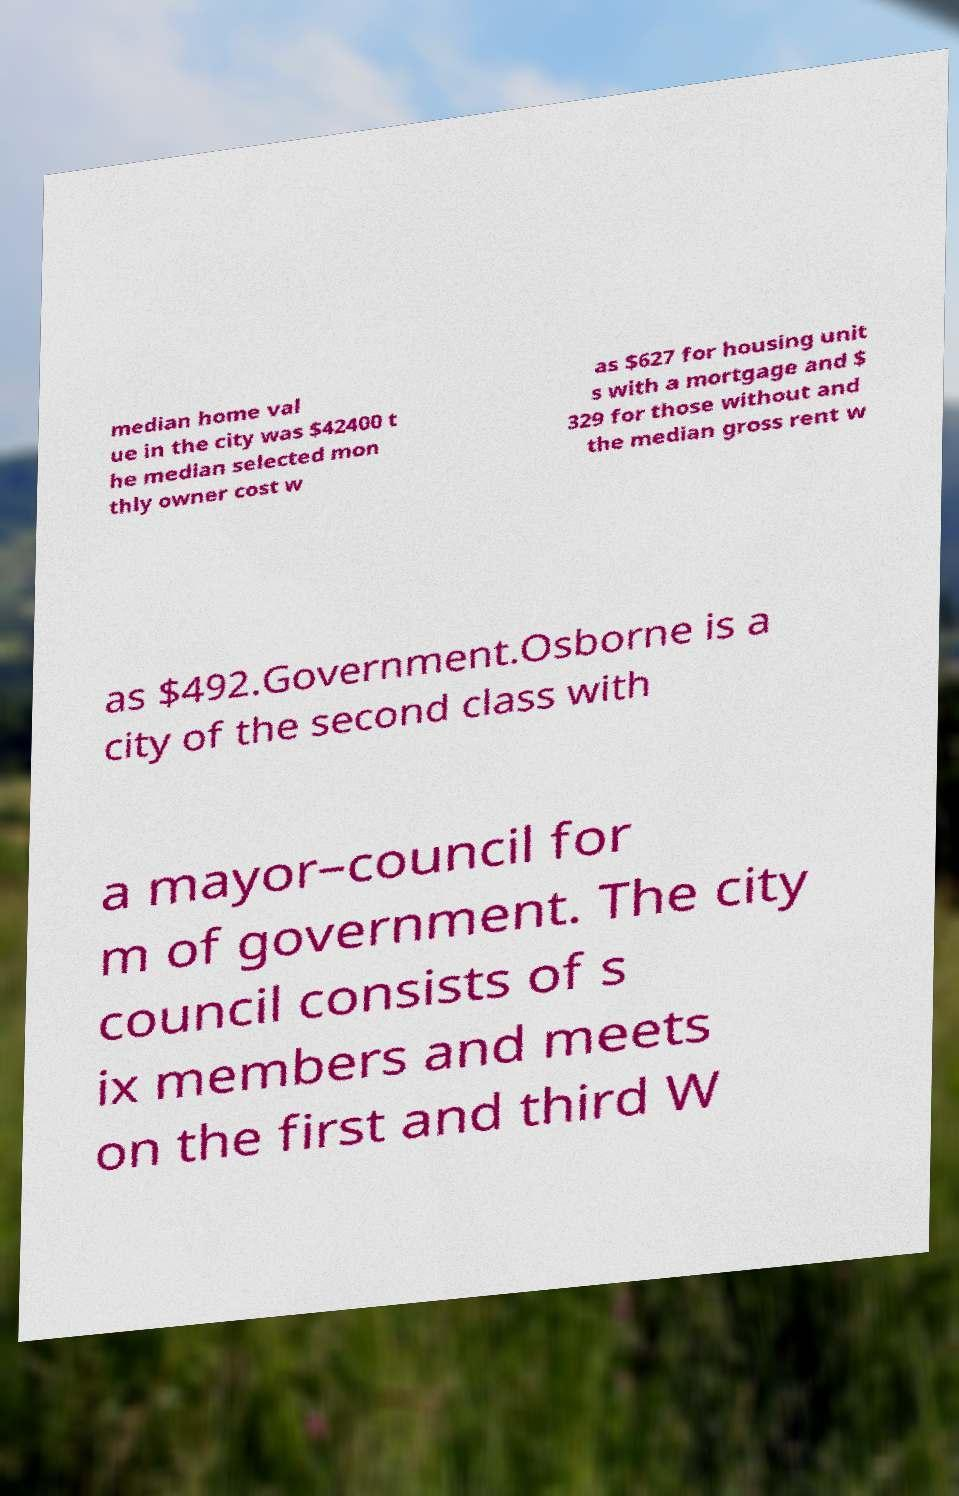Can you accurately transcribe the text from the provided image for me? median home val ue in the city was $42400 t he median selected mon thly owner cost w as $627 for housing unit s with a mortgage and $ 329 for those without and the median gross rent w as $492.Government.Osborne is a city of the second class with a mayor–council for m of government. The city council consists of s ix members and meets on the first and third W 